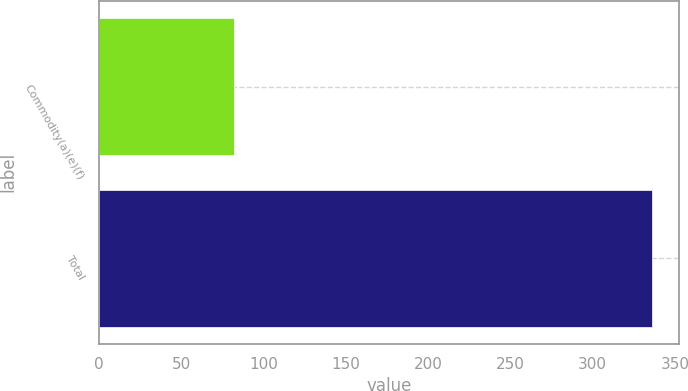Convert chart. <chart><loc_0><loc_0><loc_500><loc_500><bar_chart><fcel>Commodity(a)(e)(f)<fcel>Total<nl><fcel>82<fcel>336<nl></chart> 